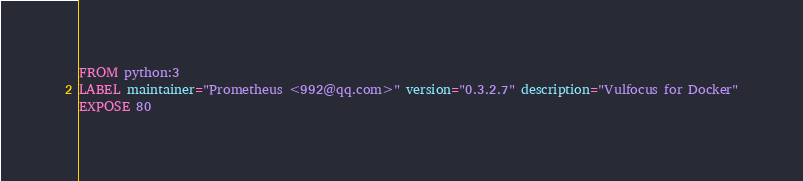<code> <loc_0><loc_0><loc_500><loc_500><_Dockerfile_>FROM python:3
LABEL maintainer="Prometheus <992@qq.com>" version="0.3.2.7" description="Vulfocus for Docker"
EXPOSE 80</code> 